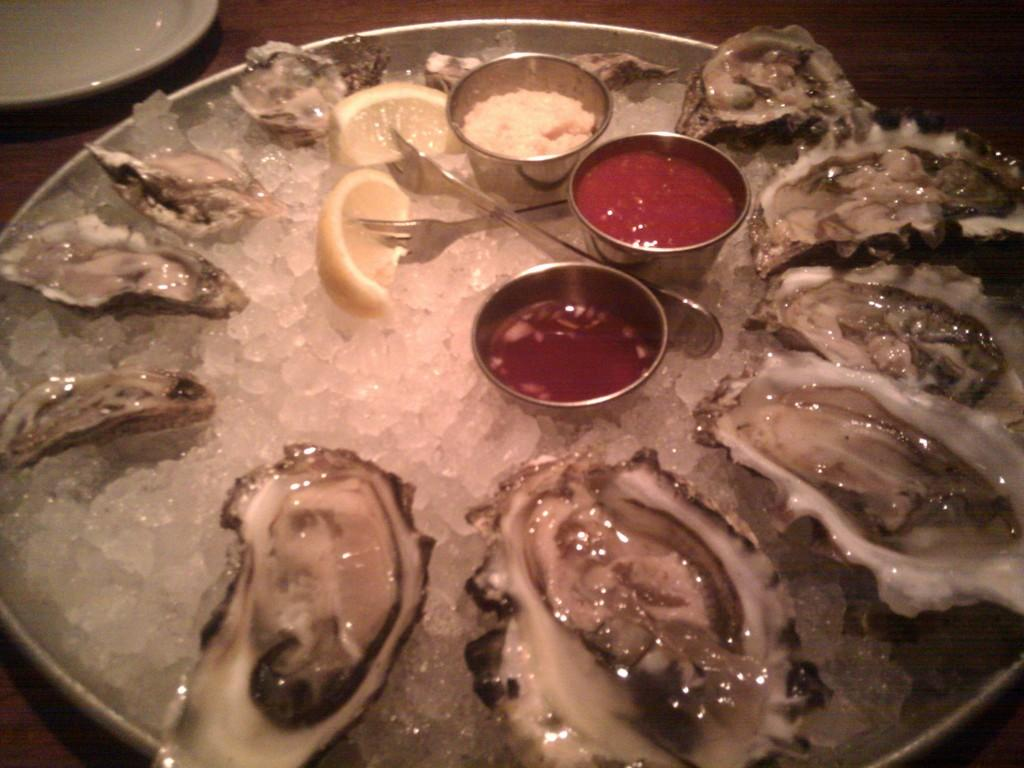What piece of furniture is present in the image? There is a table in the image. What is placed on the table? There are plates on the table. What is in the plates? There is food in the plates. What utensils are visible in the image? There are forks in the image. What type of sheet is covering the hospital bed in the image? There is no sheet or hospital bed present in the image; it features a table with plates and food. 